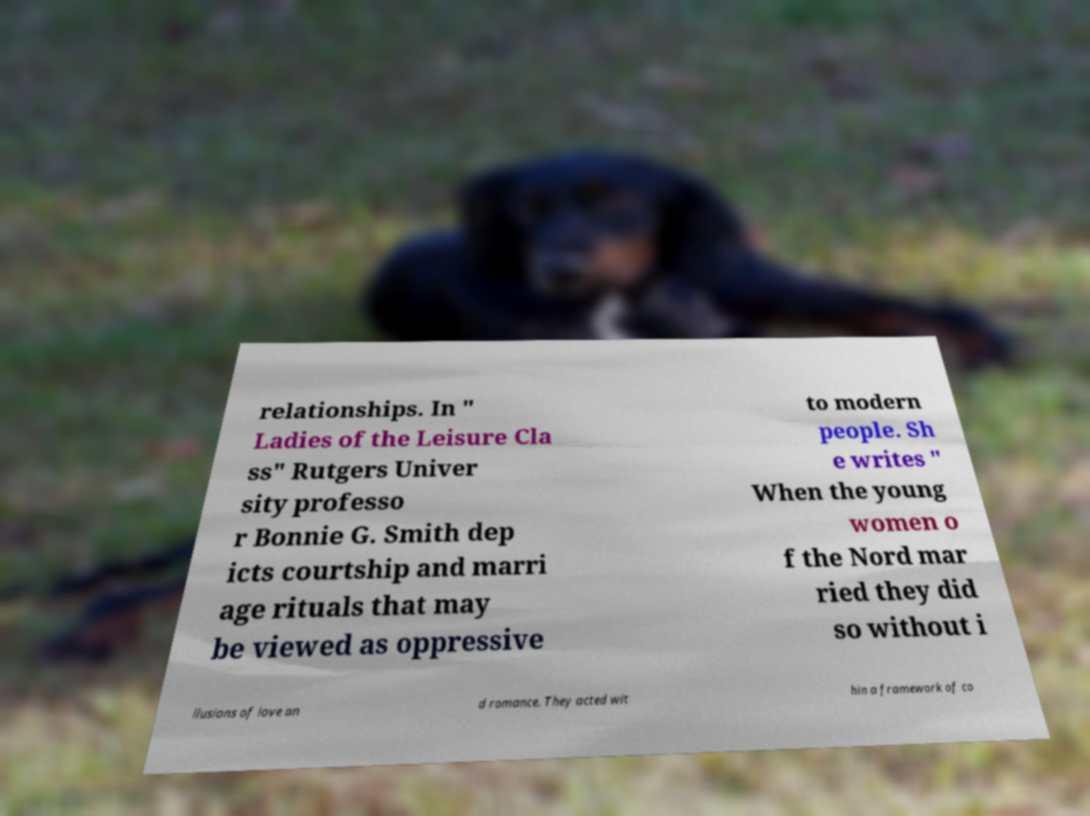There's text embedded in this image that I need extracted. Can you transcribe it verbatim? relationships. In " Ladies of the Leisure Cla ss" Rutgers Univer sity professo r Bonnie G. Smith dep icts courtship and marri age rituals that may be viewed as oppressive to modern people. Sh e writes " When the young women o f the Nord mar ried they did so without i llusions of love an d romance. They acted wit hin a framework of co 